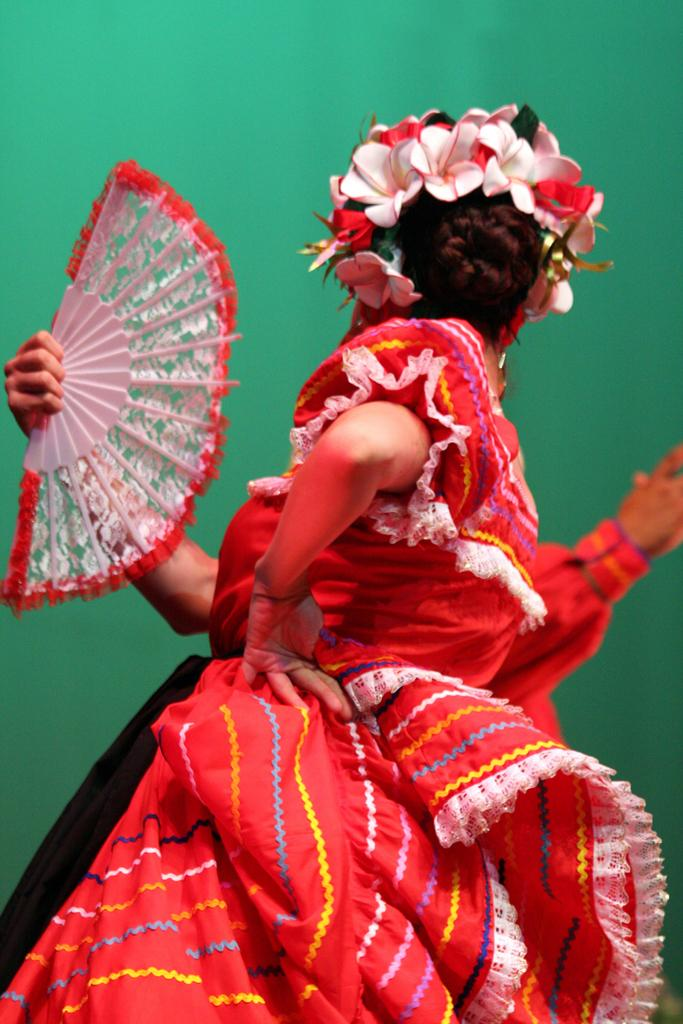Who is the main subject in the image? There is a woman in the image. What is the woman wearing? The woman is wearing a red dress. What object is the woman holding? The woman is holding a hand fan. Can you describe the person behind the woman? There is a person behind the woman, but their appearance is not specified in the facts. What kind of accessory is the woman wearing on her head? The woman is wearing flowers on her head. What color is the background of the image? The background color is green. What type of zipper can be seen on the woman's dress in the image? There is no mention of a zipper on the woman's dress in the provided facts, so it cannot be determined from the image. 